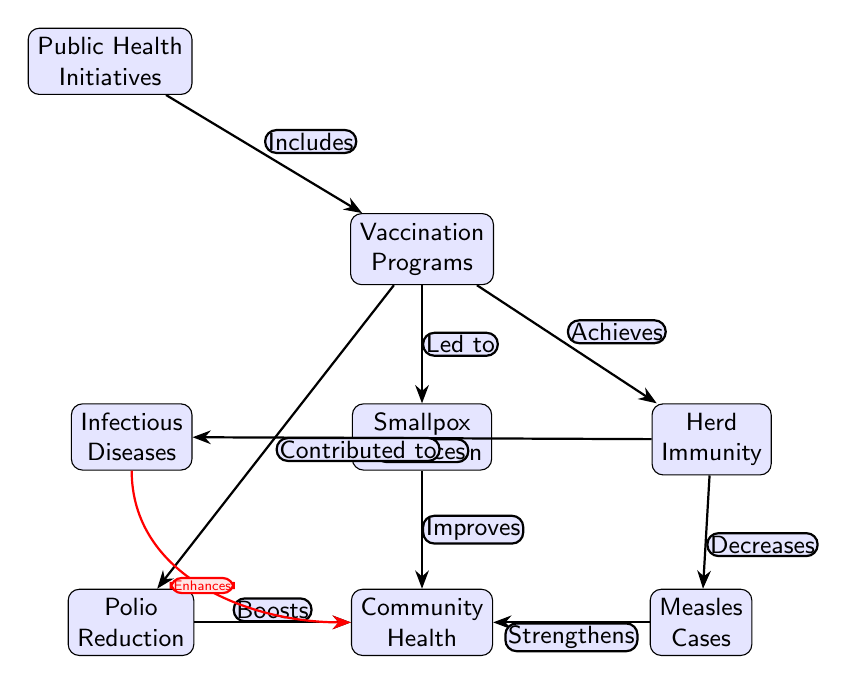What is the main focus of the diagram? The main focus of the diagram is "Public Health Initiatives," which is represented as the top node of the diagram. It serves as the starting point for the relationships shown.
Answer: Public Health Initiatives How many nodes are present in the diagram? By counting each labeled box, there are a total of eight nodes in the diagram: Public Health Initiatives, Vaccination Programs, Infectious Diseases, Herd Immunity, Smallpox Eradication, Polio Reduction, Measles Cases, and Community Health.
Answer: 8 What contribution do Vaccination Programs make to the diagram? Vaccination Programs are stated to "Lead to" Smallpox Eradication and "Contributed to" Polio Reduction in the diagram, which demonstrates their impactful role in reducing certain diseases.
Answer: Lead to Smallpox Eradication; Contributed to Polio Reduction What effect does Herd Immunity have on Infectious Diseases? The diagram states that Herd Immunity "Reduces" Infectious Diseases, which shows how higher vaccination rates within a community can lead to a decrease in the spread of diseases.
Answer: Reduces Which node directly improves Community Health? The diagram indicates that Smallpox Eradication, Polio Reduction, and Measles Cases each "Improves", "Boosts", and "Strengthens" Community Health, respectively, hence they all contribute to its improvement.
Answer: Smallpox Eradication; Polio Reduction; Measles Cases What additional effect does the reduction in Infectious Diseases have on Community Health? The diagram shows a direct relationship, where the reduction in Infectious Diseases "Enhances" Community Health, indicating that addressing infectious diseases contributes positively to overall community well-being.
Answer: Enhances What is the relationship between Vaccination Programs and Herd Immunity? According to the diagram, Vaccination Programs "Achieves" Herd Immunity, showcasing how vaccination efforts help generate immunity within the population.
Answer: Achieves How do Measles Cases influence Community Health? The diagram specifies that Measles Cases "Strengthens" Community Health, indicating that effective control of measles positively impacts health at the community level.
Answer: Strengthens 